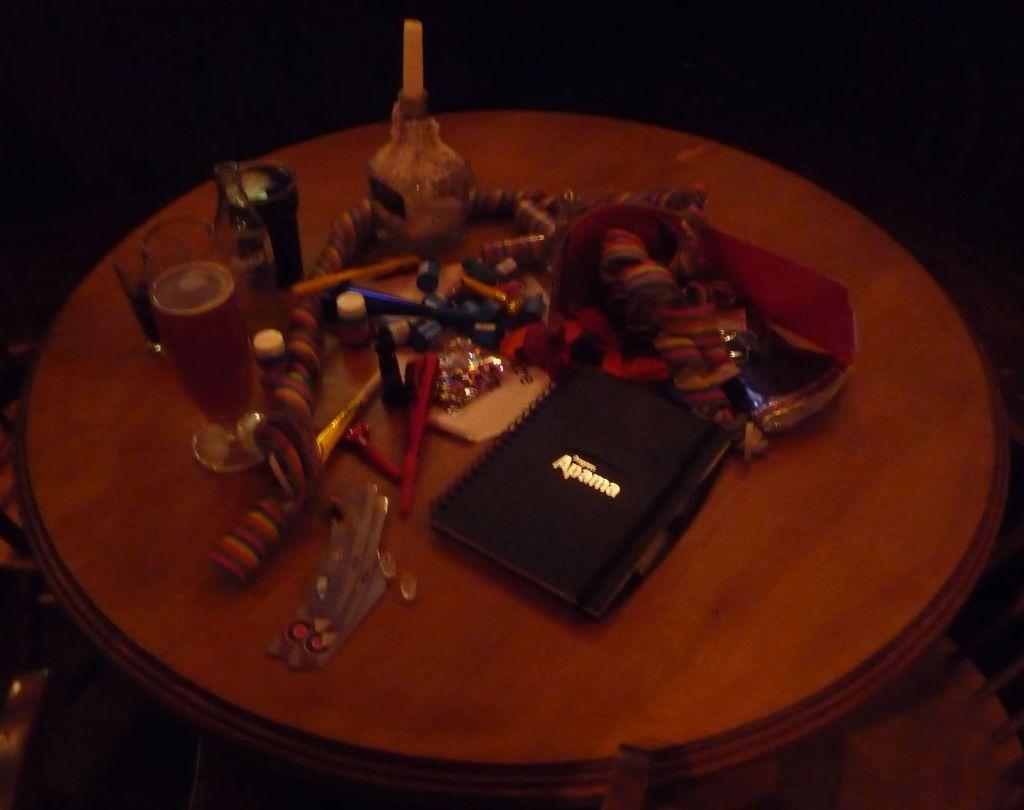Who made the book in the middle of the table?
Offer a terse response. Apama. 